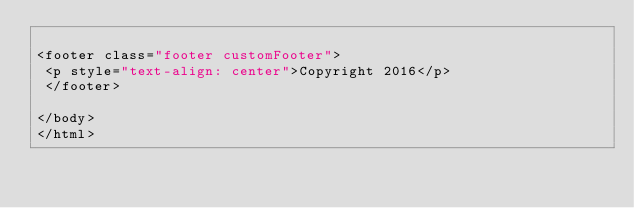<code> <loc_0><loc_0><loc_500><loc_500><_PHP_>
<footer class="footer customFooter">
 <p style="text-align: center">Copyright 2016</p>
 </footer>

</body>
</html></code> 